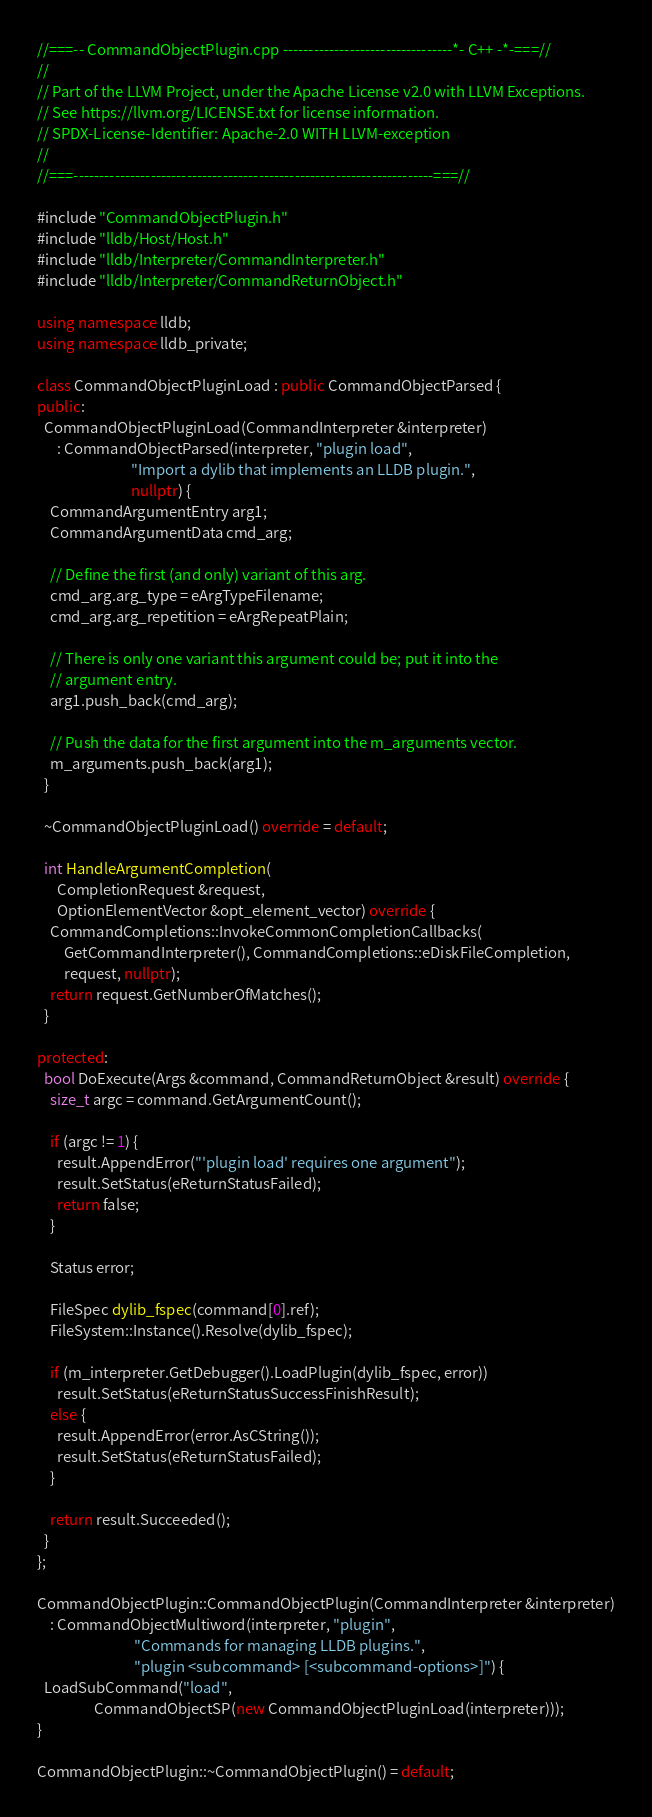Convert code to text. <code><loc_0><loc_0><loc_500><loc_500><_C++_>//===-- CommandObjectPlugin.cpp ---------------------------------*- C++ -*-===//
//
// Part of the LLVM Project, under the Apache License v2.0 with LLVM Exceptions.
// See https://llvm.org/LICENSE.txt for license information.
// SPDX-License-Identifier: Apache-2.0 WITH LLVM-exception
//
//===----------------------------------------------------------------------===//

#include "CommandObjectPlugin.h"
#include "lldb/Host/Host.h"
#include "lldb/Interpreter/CommandInterpreter.h"
#include "lldb/Interpreter/CommandReturnObject.h"

using namespace lldb;
using namespace lldb_private;

class CommandObjectPluginLoad : public CommandObjectParsed {
public:
  CommandObjectPluginLoad(CommandInterpreter &interpreter)
      : CommandObjectParsed(interpreter, "plugin load",
                            "Import a dylib that implements an LLDB plugin.",
                            nullptr) {
    CommandArgumentEntry arg1;
    CommandArgumentData cmd_arg;

    // Define the first (and only) variant of this arg.
    cmd_arg.arg_type = eArgTypeFilename;
    cmd_arg.arg_repetition = eArgRepeatPlain;

    // There is only one variant this argument could be; put it into the
    // argument entry.
    arg1.push_back(cmd_arg);

    // Push the data for the first argument into the m_arguments vector.
    m_arguments.push_back(arg1);
  }

  ~CommandObjectPluginLoad() override = default;

  int HandleArgumentCompletion(
      CompletionRequest &request,
      OptionElementVector &opt_element_vector) override {
    CommandCompletions::InvokeCommonCompletionCallbacks(
        GetCommandInterpreter(), CommandCompletions::eDiskFileCompletion,
        request, nullptr);
    return request.GetNumberOfMatches();
  }

protected:
  bool DoExecute(Args &command, CommandReturnObject &result) override {
    size_t argc = command.GetArgumentCount();

    if (argc != 1) {
      result.AppendError("'plugin load' requires one argument");
      result.SetStatus(eReturnStatusFailed);
      return false;
    }

    Status error;

    FileSpec dylib_fspec(command[0].ref);
    FileSystem::Instance().Resolve(dylib_fspec);

    if (m_interpreter.GetDebugger().LoadPlugin(dylib_fspec, error))
      result.SetStatus(eReturnStatusSuccessFinishResult);
    else {
      result.AppendError(error.AsCString());
      result.SetStatus(eReturnStatusFailed);
    }

    return result.Succeeded();
  }
};

CommandObjectPlugin::CommandObjectPlugin(CommandInterpreter &interpreter)
    : CommandObjectMultiword(interpreter, "plugin",
                             "Commands for managing LLDB plugins.",
                             "plugin <subcommand> [<subcommand-options>]") {
  LoadSubCommand("load",
                 CommandObjectSP(new CommandObjectPluginLoad(interpreter)));
}

CommandObjectPlugin::~CommandObjectPlugin() = default;
</code> 